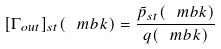Convert formula to latex. <formula><loc_0><loc_0><loc_500><loc_500>[ \Gamma _ { o u t } ] _ { s t } ( \ m b k ) = \frac { \tilde { p } _ { s t } ( \ m b k ) } { q ( \ m b k ) }</formula> 